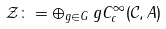Convert formula to latex. <formula><loc_0><loc_0><loc_500><loc_500>\mathcal { Z } \colon = \oplus _ { g \in G } \, g C ^ { \infty } _ { c } ( \mathcal { C } , A )</formula> 